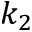Convert formula to latex. <formula><loc_0><loc_0><loc_500><loc_500>k _ { 2 }</formula> 